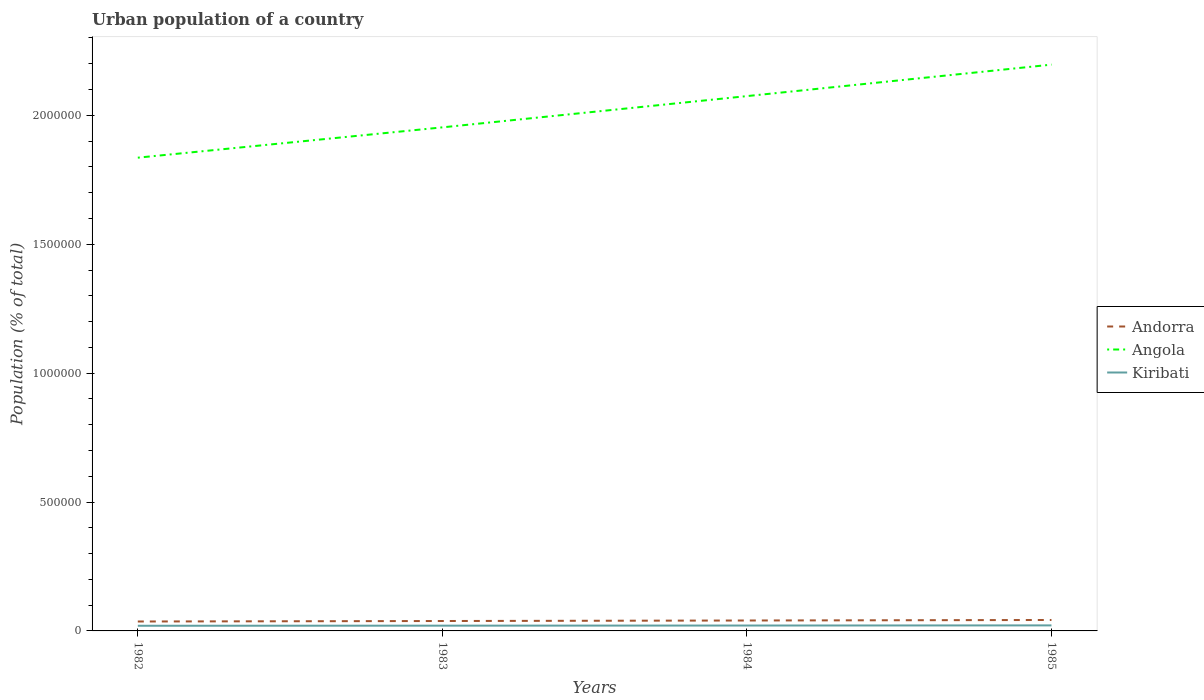How many different coloured lines are there?
Offer a very short reply. 3. Does the line corresponding to Kiribati intersect with the line corresponding to Angola?
Keep it short and to the point. No. Is the number of lines equal to the number of legend labels?
Offer a very short reply. Yes. Across all years, what is the maximum urban population in Kiribati?
Your answer should be compact. 2.00e+04. In which year was the urban population in Andorra maximum?
Your response must be concise. 1982. What is the total urban population in Kiribati in the graph?
Give a very brief answer. -922. What is the difference between the highest and the second highest urban population in Kiribati?
Offer a very short reply. 1498. Is the urban population in Andorra strictly greater than the urban population in Angola over the years?
Your answer should be very brief. Yes. How many lines are there?
Give a very brief answer. 3. How many years are there in the graph?
Provide a short and direct response. 4. Does the graph contain any zero values?
Make the answer very short. No. Does the graph contain grids?
Give a very brief answer. No. Where does the legend appear in the graph?
Give a very brief answer. Center right. How many legend labels are there?
Your answer should be compact. 3. What is the title of the graph?
Offer a terse response. Urban population of a country. What is the label or title of the Y-axis?
Ensure brevity in your answer.  Population (% of total). What is the Population (% of total) in Andorra in 1982?
Make the answer very short. 3.66e+04. What is the Population (% of total) of Angola in 1982?
Your response must be concise. 1.84e+06. What is the Population (% of total) in Kiribati in 1982?
Make the answer very short. 2.00e+04. What is the Population (% of total) in Andorra in 1983?
Ensure brevity in your answer.  3.84e+04. What is the Population (% of total) of Angola in 1983?
Give a very brief answer. 1.95e+06. What is the Population (% of total) in Kiribati in 1983?
Offer a very short reply. 2.04e+04. What is the Population (% of total) in Andorra in 1984?
Keep it short and to the point. 4.04e+04. What is the Population (% of total) in Angola in 1984?
Your answer should be very brief. 2.07e+06. What is the Population (% of total) in Kiribati in 1984?
Give a very brief answer. 2.09e+04. What is the Population (% of total) of Andorra in 1985?
Provide a succinct answer. 4.24e+04. What is the Population (% of total) of Angola in 1985?
Your response must be concise. 2.20e+06. What is the Population (% of total) of Kiribati in 1985?
Provide a succinct answer. 2.15e+04. Across all years, what is the maximum Population (% of total) of Andorra?
Offer a very short reply. 4.24e+04. Across all years, what is the maximum Population (% of total) of Angola?
Offer a very short reply. 2.20e+06. Across all years, what is the maximum Population (% of total) in Kiribati?
Provide a short and direct response. 2.15e+04. Across all years, what is the minimum Population (% of total) of Andorra?
Your answer should be compact. 3.66e+04. Across all years, what is the minimum Population (% of total) of Angola?
Provide a short and direct response. 1.84e+06. Across all years, what is the minimum Population (% of total) of Kiribati?
Provide a short and direct response. 2.00e+04. What is the total Population (% of total) in Andorra in the graph?
Provide a succinct answer. 1.58e+05. What is the total Population (% of total) of Angola in the graph?
Keep it short and to the point. 8.06e+06. What is the total Population (% of total) of Kiribati in the graph?
Provide a succinct answer. 8.27e+04. What is the difference between the Population (% of total) of Andorra in 1982 and that in 1983?
Offer a very short reply. -1887. What is the difference between the Population (% of total) of Angola in 1982 and that in 1983?
Offer a terse response. -1.18e+05. What is the difference between the Population (% of total) in Kiribati in 1982 and that in 1983?
Your response must be concise. -431. What is the difference between the Population (% of total) in Andorra in 1982 and that in 1984?
Keep it short and to the point. -3859. What is the difference between the Population (% of total) in Angola in 1982 and that in 1984?
Give a very brief answer. -2.39e+05. What is the difference between the Population (% of total) in Kiribati in 1982 and that in 1984?
Make the answer very short. -922. What is the difference between the Population (% of total) in Andorra in 1982 and that in 1985?
Ensure brevity in your answer.  -5878. What is the difference between the Population (% of total) of Angola in 1982 and that in 1985?
Ensure brevity in your answer.  -3.61e+05. What is the difference between the Population (% of total) in Kiribati in 1982 and that in 1985?
Make the answer very short. -1498. What is the difference between the Population (% of total) of Andorra in 1983 and that in 1984?
Your answer should be very brief. -1972. What is the difference between the Population (% of total) in Angola in 1983 and that in 1984?
Give a very brief answer. -1.21e+05. What is the difference between the Population (% of total) in Kiribati in 1983 and that in 1984?
Provide a short and direct response. -491. What is the difference between the Population (% of total) of Andorra in 1983 and that in 1985?
Provide a short and direct response. -3991. What is the difference between the Population (% of total) of Angola in 1983 and that in 1985?
Provide a succinct answer. -2.43e+05. What is the difference between the Population (% of total) in Kiribati in 1983 and that in 1985?
Keep it short and to the point. -1067. What is the difference between the Population (% of total) of Andorra in 1984 and that in 1985?
Ensure brevity in your answer.  -2019. What is the difference between the Population (% of total) in Angola in 1984 and that in 1985?
Give a very brief answer. -1.22e+05. What is the difference between the Population (% of total) of Kiribati in 1984 and that in 1985?
Offer a terse response. -576. What is the difference between the Population (% of total) in Andorra in 1982 and the Population (% of total) in Angola in 1983?
Ensure brevity in your answer.  -1.92e+06. What is the difference between the Population (% of total) in Andorra in 1982 and the Population (% of total) in Kiribati in 1983?
Your answer should be compact. 1.62e+04. What is the difference between the Population (% of total) in Angola in 1982 and the Population (% of total) in Kiribati in 1983?
Your response must be concise. 1.82e+06. What is the difference between the Population (% of total) of Andorra in 1982 and the Population (% of total) of Angola in 1984?
Your answer should be compact. -2.04e+06. What is the difference between the Population (% of total) in Andorra in 1982 and the Population (% of total) in Kiribati in 1984?
Keep it short and to the point. 1.57e+04. What is the difference between the Population (% of total) of Angola in 1982 and the Population (% of total) of Kiribati in 1984?
Keep it short and to the point. 1.81e+06. What is the difference between the Population (% of total) in Andorra in 1982 and the Population (% of total) in Angola in 1985?
Offer a very short reply. -2.16e+06. What is the difference between the Population (% of total) in Andorra in 1982 and the Population (% of total) in Kiribati in 1985?
Offer a terse response. 1.51e+04. What is the difference between the Population (% of total) in Angola in 1982 and the Population (% of total) in Kiribati in 1985?
Provide a short and direct response. 1.81e+06. What is the difference between the Population (% of total) of Andorra in 1983 and the Population (% of total) of Angola in 1984?
Keep it short and to the point. -2.04e+06. What is the difference between the Population (% of total) of Andorra in 1983 and the Population (% of total) of Kiribati in 1984?
Offer a terse response. 1.76e+04. What is the difference between the Population (% of total) of Angola in 1983 and the Population (% of total) of Kiribati in 1984?
Provide a short and direct response. 1.93e+06. What is the difference between the Population (% of total) in Andorra in 1983 and the Population (% of total) in Angola in 1985?
Provide a succinct answer. -2.16e+06. What is the difference between the Population (% of total) of Andorra in 1983 and the Population (% of total) of Kiribati in 1985?
Your answer should be compact. 1.70e+04. What is the difference between the Population (% of total) of Angola in 1983 and the Population (% of total) of Kiribati in 1985?
Keep it short and to the point. 1.93e+06. What is the difference between the Population (% of total) of Andorra in 1984 and the Population (% of total) of Angola in 1985?
Make the answer very short. -2.16e+06. What is the difference between the Population (% of total) of Andorra in 1984 and the Population (% of total) of Kiribati in 1985?
Your answer should be compact. 1.90e+04. What is the difference between the Population (% of total) in Angola in 1984 and the Population (% of total) in Kiribati in 1985?
Make the answer very short. 2.05e+06. What is the average Population (% of total) of Andorra per year?
Make the answer very short. 3.95e+04. What is the average Population (% of total) in Angola per year?
Your answer should be compact. 2.02e+06. What is the average Population (% of total) in Kiribati per year?
Provide a short and direct response. 2.07e+04. In the year 1982, what is the difference between the Population (% of total) of Andorra and Population (% of total) of Angola?
Give a very brief answer. -1.80e+06. In the year 1982, what is the difference between the Population (% of total) of Andorra and Population (% of total) of Kiribati?
Make the answer very short. 1.66e+04. In the year 1982, what is the difference between the Population (% of total) of Angola and Population (% of total) of Kiribati?
Offer a very short reply. 1.82e+06. In the year 1983, what is the difference between the Population (% of total) of Andorra and Population (% of total) of Angola?
Offer a very short reply. -1.91e+06. In the year 1983, what is the difference between the Population (% of total) in Andorra and Population (% of total) in Kiribati?
Keep it short and to the point. 1.80e+04. In the year 1983, what is the difference between the Population (% of total) of Angola and Population (% of total) of Kiribati?
Offer a very short reply. 1.93e+06. In the year 1984, what is the difference between the Population (% of total) of Andorra and Population (% of total) of Angola?
Offer a terse response. -2.03e+06. In the year 1984, what is the difference between the Population (% of total) of Andorra and Population (% of total) of Kiribati?
Make the answer very short. 1.95e+04. In the year 1984, what is the difference between the Population (% of total) of Angola and Population (% of total) of Kiribati?
Give a very brief answer. 2.05e+06. In the year 1985, what is the difference between the Population (% of total) in Andorra and Population (% of total) in Angola?
Your answer should be very brief. -2.15e+06. In the year 1985, what is the difference between the Population (% of total) in Andorra and Population (% of total) in Kiribati?
Ensure brevity in your answer.  2.10e+04. In the year 1985, what is the difference between the Population (% of total) of Angola and Population (% of total) of Kiribati?
Provide a succinct answer. 2.18e+06. What is the ratio of the Population (% of total) of Andorra in 1982 to that in 1983?
Offer a terse response. 0.95. What is the ratio of the Population (% of total) in Angola in 1982 to that in 1983?
Your response must be concise. 0.94. What is the ratio of the Population (% of total) in Kiribati in 1982 to that in 1983?
Offer a terse response. 0.98. What is the ratio of the Population (% of total) of Andorra in 1982 to that in 1984?
Your answer should be compact. 0.9. What is the ratio of the Population (% of total) of Angola in 1982 to that in 1984?
Give a very brief answer. 0.88. What is the ratio of the Population (% of total) of Kiribati in 1982 to that in 1984?
Offer a terse response. 0.96. What is the ratio of the Population (% of total) in Andorra in 1982 to that in 1985?
Keep it short and to the point. 0.86. What is the ratio of the Population (% of total) of Angola in 1982 to that in 1985?
Give a very brief answer. 0.84. What is the ratio of the Population (% of total) of Kiribati in 1982 to that in 1985?
Your answer should be very brief. 0.93. What is the ratio of the Population (% of total) in Andorra in 1983 to that in 1984?
Provide a short and direct response. 0.95. What is the ratio of the Population (% of total) in Angola in 1983 to that in 1984?
Give a very brief answer. 0.94. What is the ratio of the Population (% of total) of Kiribati in 1983 to that in 1984?
Your response must be concise. 0.98. What is the ratio of the Population (% of total) in Andorra in 1983 to that in 1985?
Offer a terse response. 0.91. What is the ratio of the Population (% of total) in Angola in 1983 to that in 1985?
Offer a very short reply. 0.89. What is the ratio of the Population (% of total) of Kiribati in 1983 to that in 1985?
Offer a very short reply. 0.95. What is the ratio of the Population (% of total) of Kiribati in 1984 to that in 1985?
Ensure brevity in your answer.  0.97. What is the difference between the highest and the second highest Population (% of total) of Andorra?
Your answer should be compact. 2019. What is the difference between the highest and the second highest Population (% of total) in Angola?
Your answer should be very brief. 1.22e+05. What is the difference between the highest and the second highest Population (% of total) of Kiribati?
Provide a succinct answer. 576. What is the difference between the highest and the lowest Population (% of total) in Andorra?
Your response must be concise. 5878. What is the difference between the highest and the lowest Population (% of total) in Angola?
Offer a very short reply. 3.61e+05. What is the difference between the highest and the lowest Population (% of total) of Kiribati?
Your answer should be very brief. 1498. 